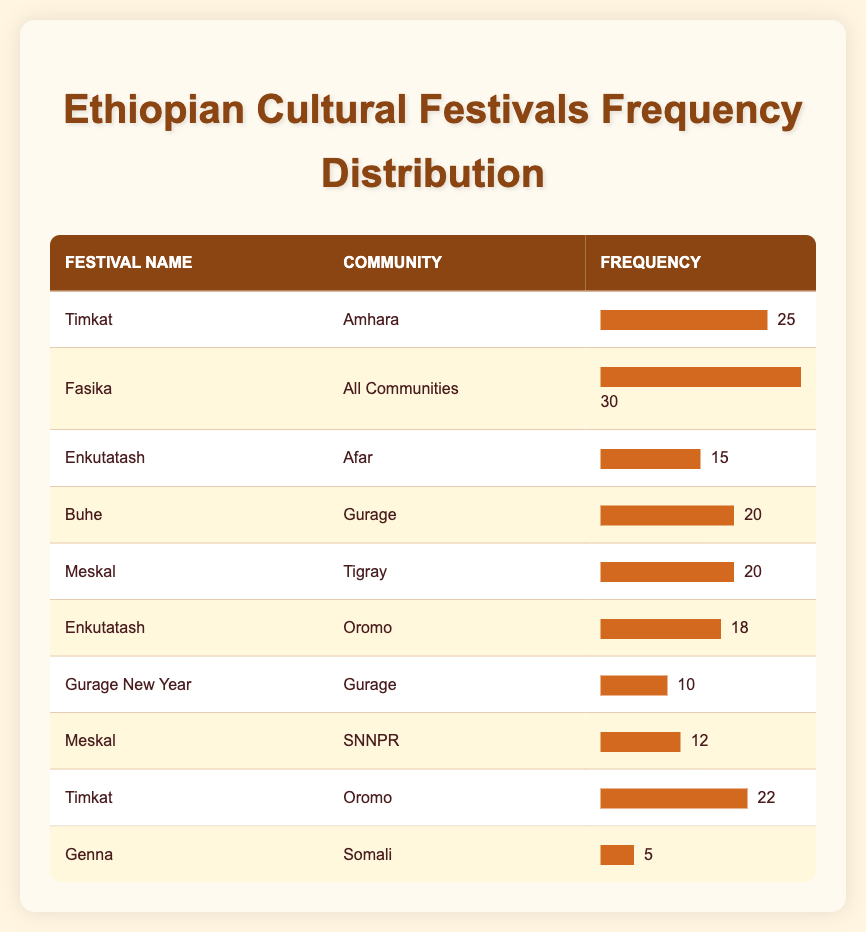What is the most frequently celebrated cultural festival across Ethiopian communities? The festival with the highest frequency in the table is "Fasika," celebrated across all communities, with a frequency of 30.
Answer: Fasika How many festivals are celebrated by the Gurage community? There are two festivals listed for the Gurage community: "Buhe" and "Gurage New Year."
Answer: 2 What is the total frequency of Timkat celebrated by both Amhara and Oromo communities? For the Amhara community, the frequency of Timkat is 25, and for the Oromo community, it is 22. Adding them together gives 25 + 22 = 47.
Answer: 47 Is Meskal celebrated by more communities than Enkutatash? Meskal is celebrated by two communities (Tigray and SNNPR), while Enkutatash is celebrated by two communities as well (Afar and Oromo), so the statement is false because they are equal.
Answer: No What is the average frequency of cultural festivals celebrated by the Gurage community? The festivals for the Gurage community are "Buhe" with a frequency of 20 and "Gurage New Year" with a frequency of 10. The average is (20 + 10) / 2 = 15.
Answer: 15 Which cultural festival has the lowest frequency, and what is that frequency? The festival with the lowest frequency is "Genna," celebrated by the Somali community, and it has a frequency of 5.
Answer: 5 What is the combined frequency of festivals celebrated by all communities? Summing all the frequencies from the table gives us 25 (Timkat, Amhara) + 30 (Fasika, All Communities) + 15 (Enkutatash, Afar) + 20 (Buhe, Gurage) + 20 (Meskal, Tigray) + 18 (Enkutatash, Oromo) + 10 (Gurage New Year, Gurage) + 12 (Meskal, SNNPR) + 22 (Timkat, Oromo) + 5 (Genna, Somali) = 252.
Answer: 252 What percentage of the total frequency does the festival Fasika represent? The total frequency is 252. The frequency of Fasika is 30. To find the percentage, we calculate (30 / 252) * 100, which is approximately 11.90%.
Answer: 11.90% 